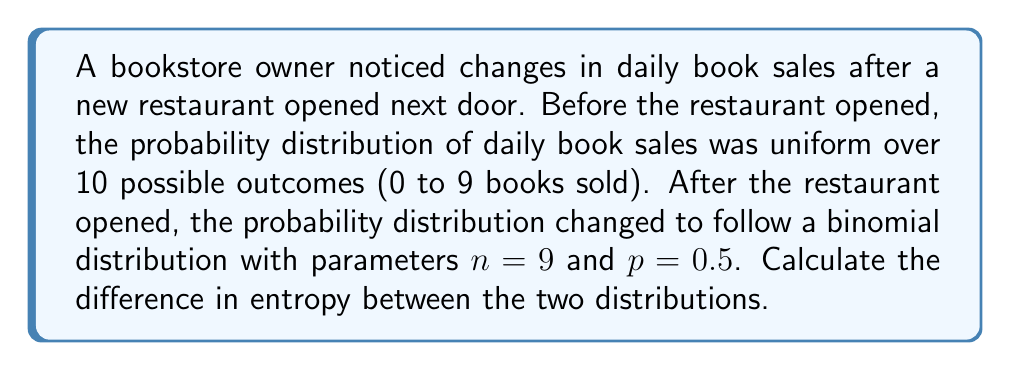Solve this math problem. To solve this problem, we need to calculate the entropy for both distributions and then find their difference.

Step 1: Calculate the entropy of the uniform distribution (before the restaurant opened)

For a uniform distribution with $N$ equally likely outcomes, the entropy is given by:

$$ S_1 = -\sum_{i=1}^N p_i \log_2(p_i) = \log_2(N) $$

In this case, $N = 10$, so:

$$ S_1 = \log_2(10) \approx 3.32193 \text{ bits} $$

Step 2: Calculate the entropy of the binomial distribution (after the restaurant opened)

For a binomial distribution with parameters $n$ and $p$, the probability of $k$ successes is given by:

$$ P(X = k) = \binom{n}{k} p^k (1-p)^{n-k} $$

The entropy is calculated using:

$$ S_2 = -\sum_{k=0}^n P(X = k) \log_2(P(X = k)) $$

For $n=9$ and $p=0.5$:

$$ S_2 = -\sum_{k=0}^9 \binom{9}{k} (0.5)^9 \log_2(\binom{9}{k} (0.5)^9) $$

Calculating this sum (which can be done numerically):

$$ S_2 \approx 2.94429 \text{ bits} $$

Step 3: Calculate the difference in entropy

$$ \Delta S = S_1 - S_2 = 3.32193 - 2.94429 \approx 0.37764 \text{ bits} $$
Answer: $0.37764 \text{ bits}$ 